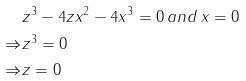Convert formula to latex. <formula><loc_0><loc_0><loc_500><loc_500>& z ^ { 3 } - 4 z x ^ { 2 } - 4 x ^ { 3 } = 0 \, a n d \, x = 0 \\ \Rightarrow & z ^ { 3 } = 0 \\ \Rightarrow & z = 0</formula> 